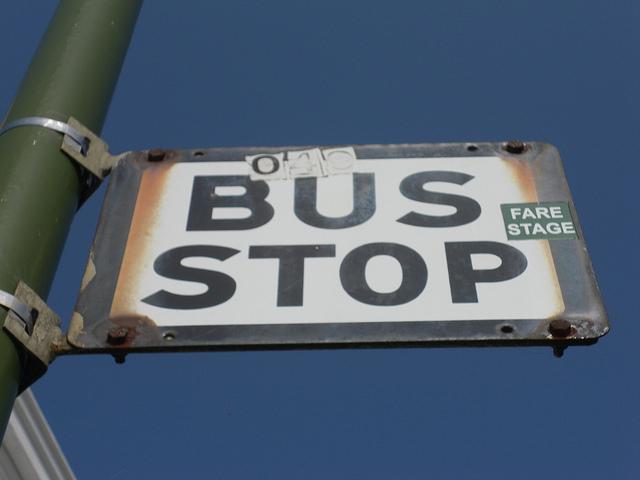What numbers are on the sign?
Keep it brief. 0. What does the sign say?
Quick response, please. Bus stop. Is this a newly painted sign?
Answer briefly. No. 